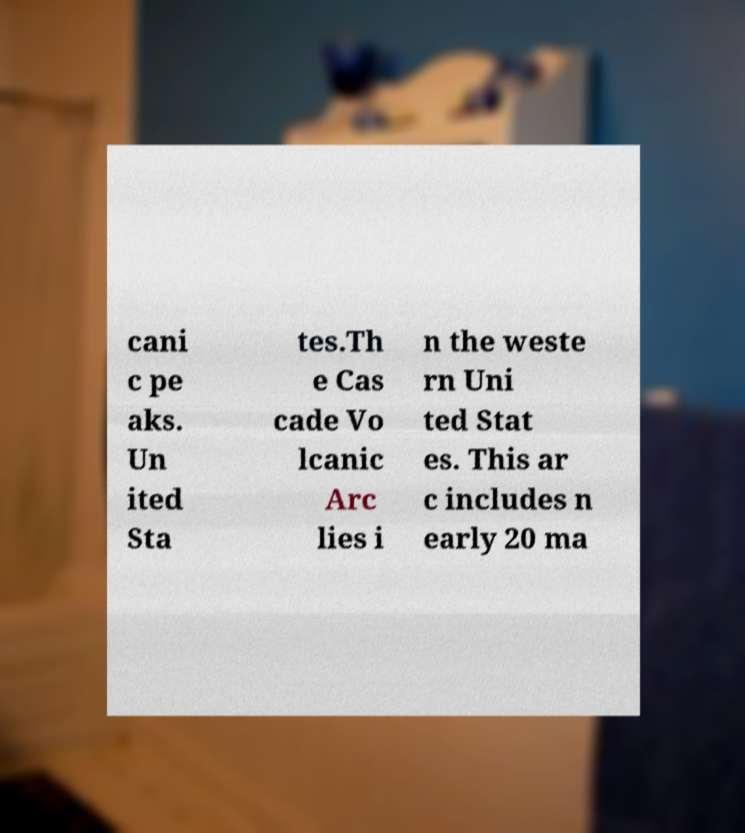Please read and relay the text visible in this image. What does it say? cani c pe aks. Un ited Sta tes.Th e Cas cade Vo lcanic Arc lies i n the weste rn Uni ted Stat es. This ar c includes n early 20 ma 